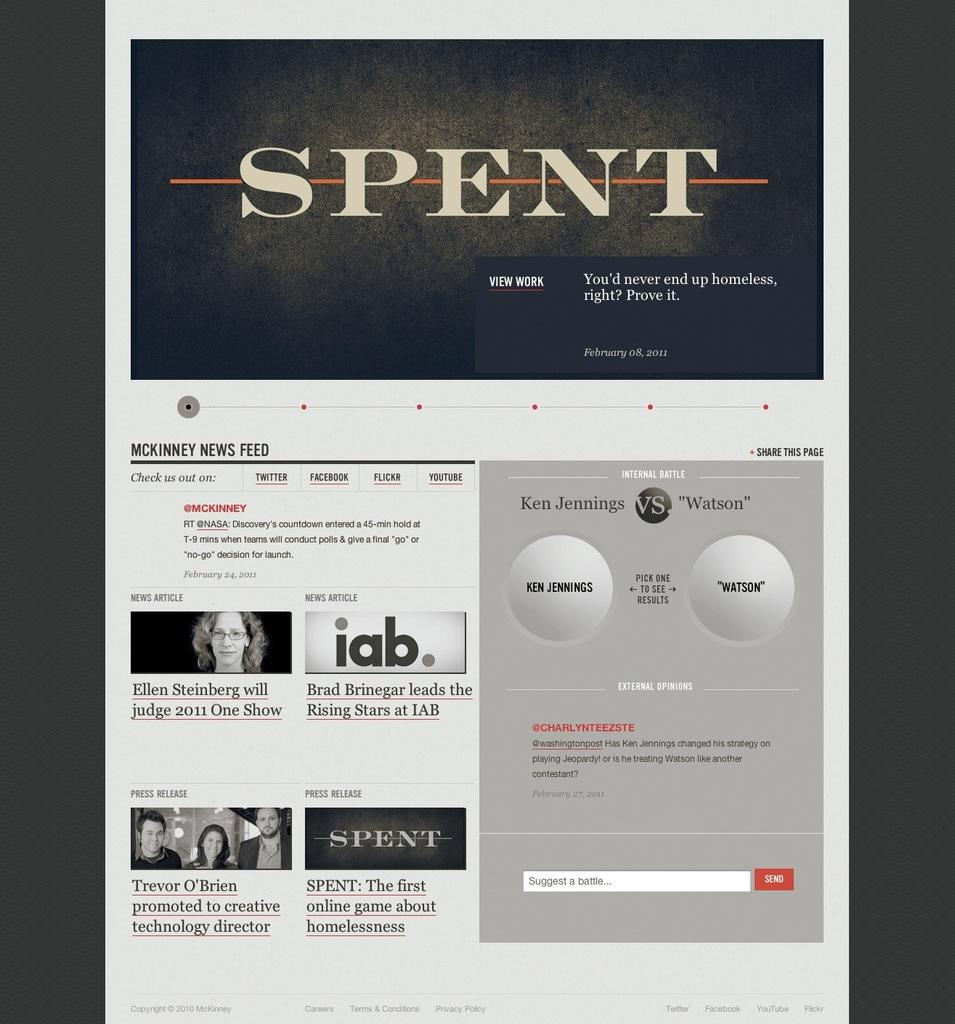<image>
Render a clear and concise summary of the photo. A page with the title header Spent talking about a game. 